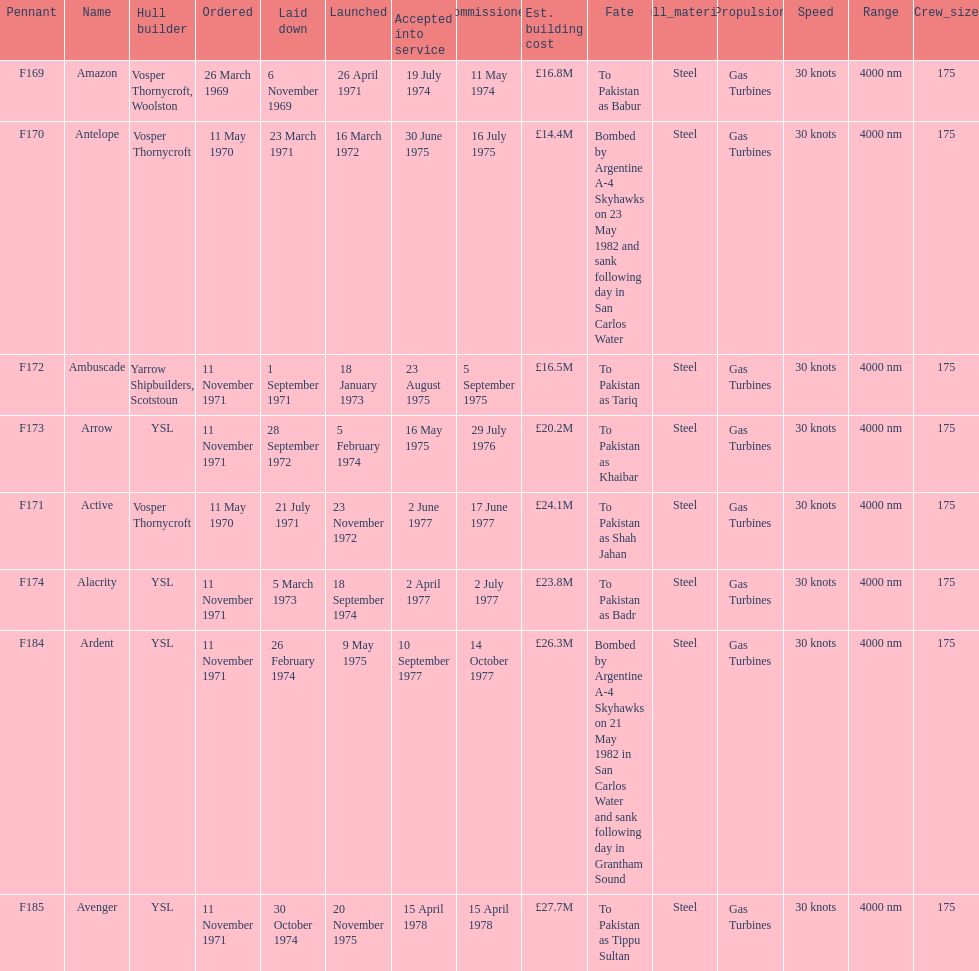How many ships were built after ardent? 1. 